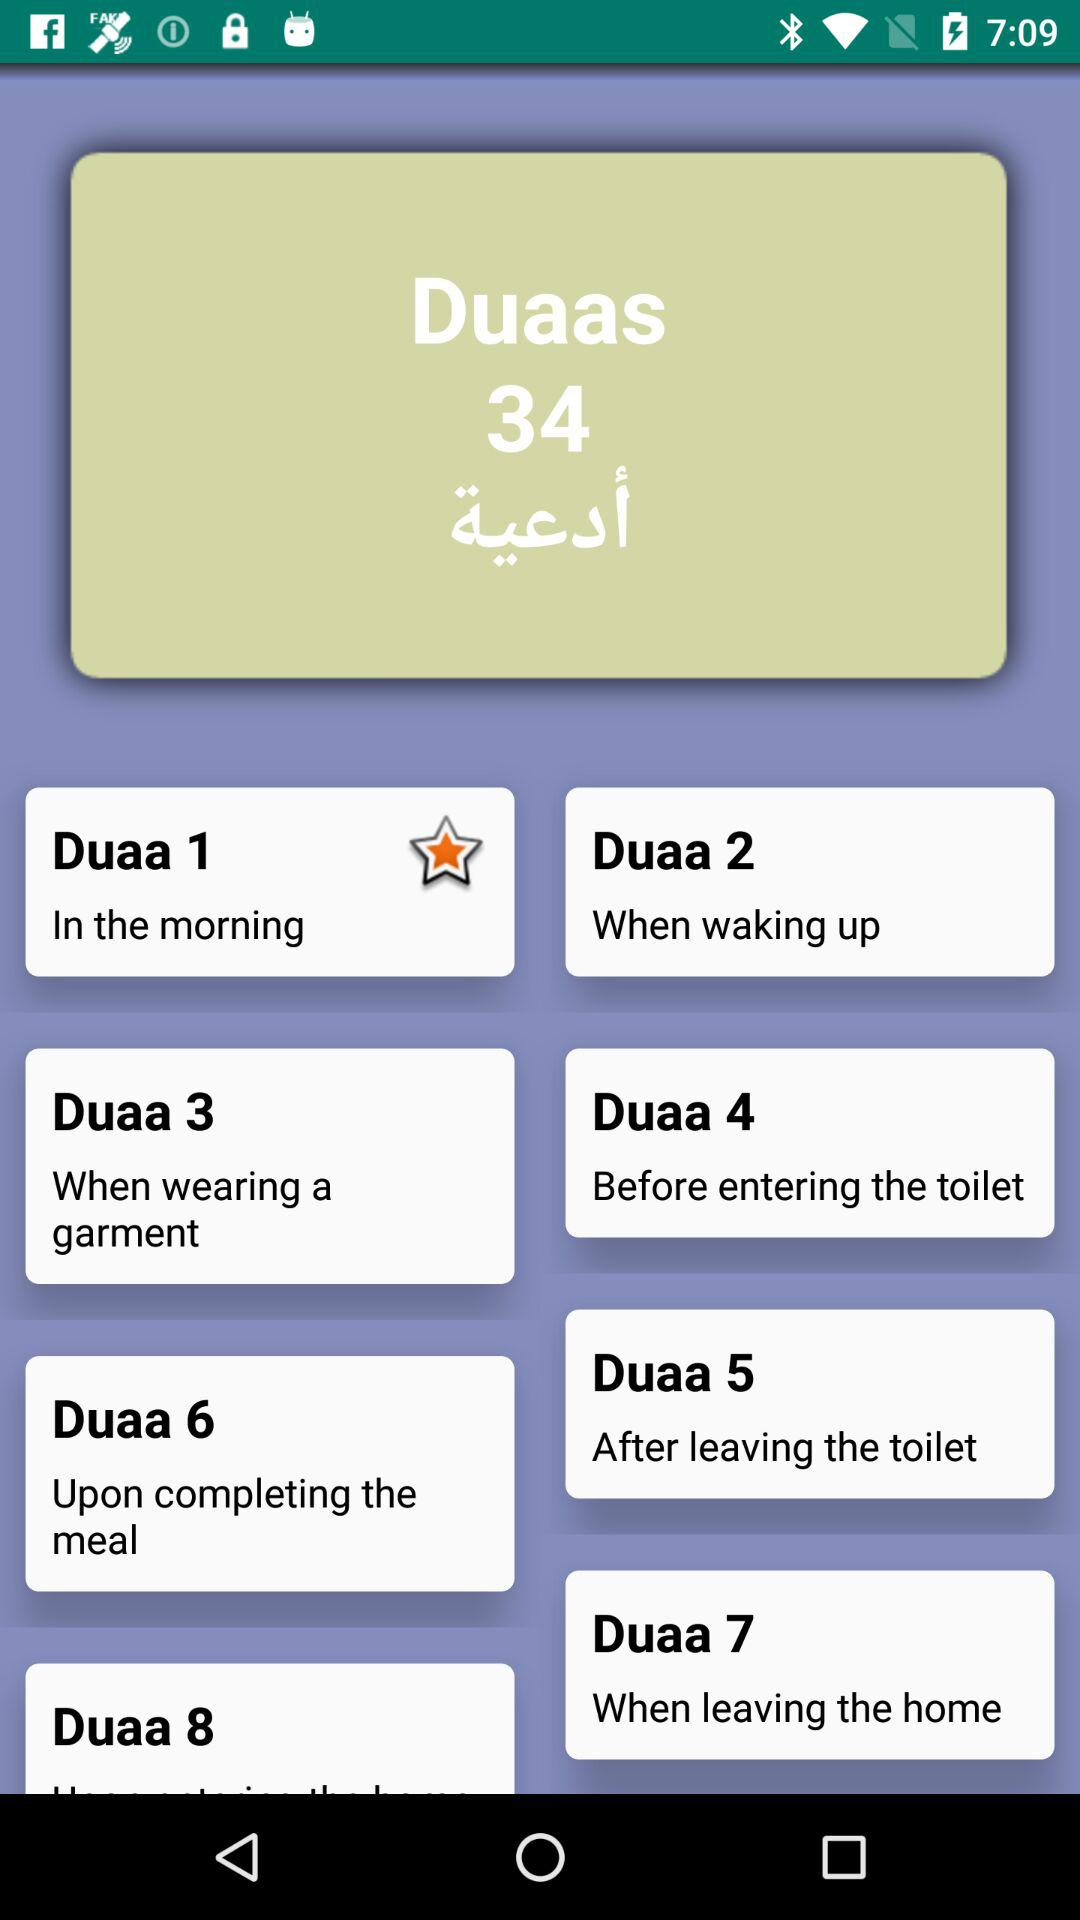When is "Duaa 6" recited? "Duaa 6" is recited upon completing the meal. 